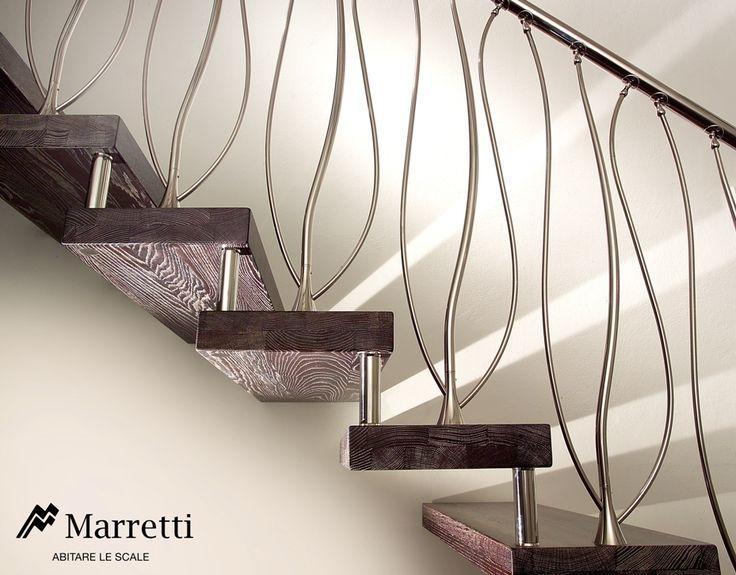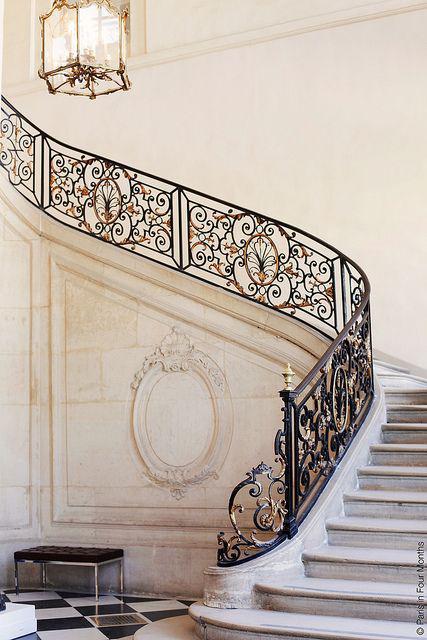The first image is the image on the left, the second image is the image on the right. Considering the images on both sides, is "One set of stairs has partly silver colored railings." valid? Answer yes or no. Yes. The first image is the image on the left, the second image is the image on the right. Analyze the images presented: Is the assertion "The staircases in both images have metal railings." valid? Answer yes or no. Yes. 